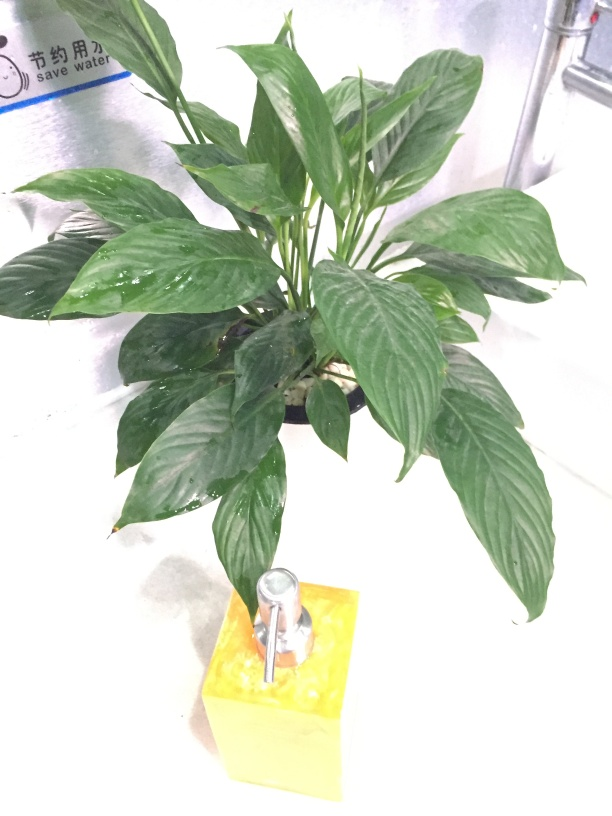What can you tell me about the object at the base of the plant? This appears to be a yellow watering device, possibly with a built-in water pump. It's likely used to irrigate the plant, ensuring it receives the appropriate amount of water without the need for frequent manual watering. 